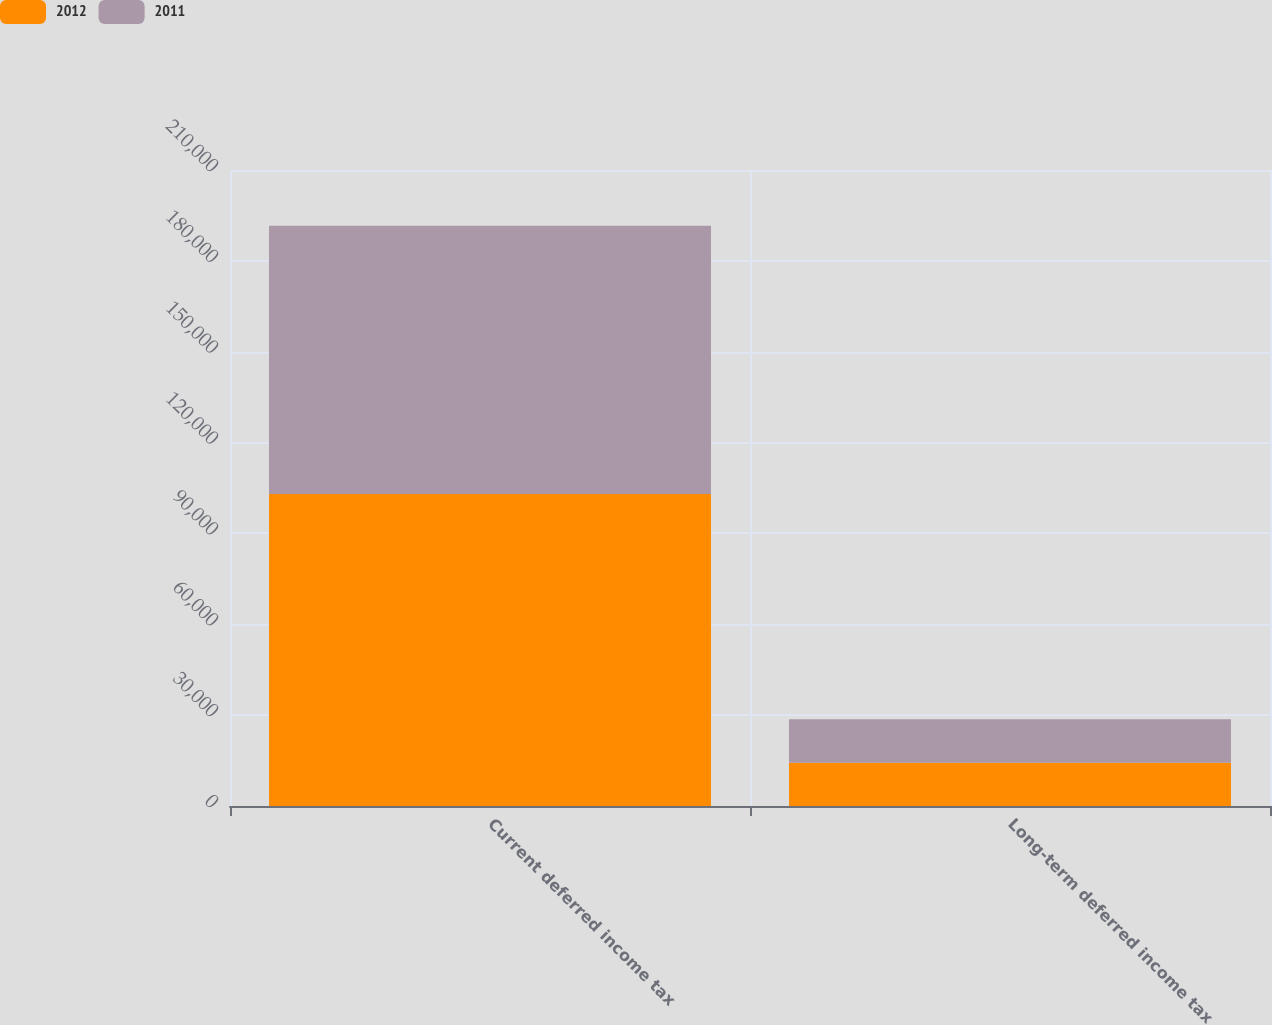Convert chart to OTSL. <chart><loc_0><loc_0><loc_500><loc_500><stacked_bar_chart><ecel><fcel>Current deferred income tax<fcel>Long-term deferred income tax<nl><fcel>2012<fcel>102993<fcel>14244<nl><fcel>2011<fcel>88578<fcel>14377<nl></chart> 